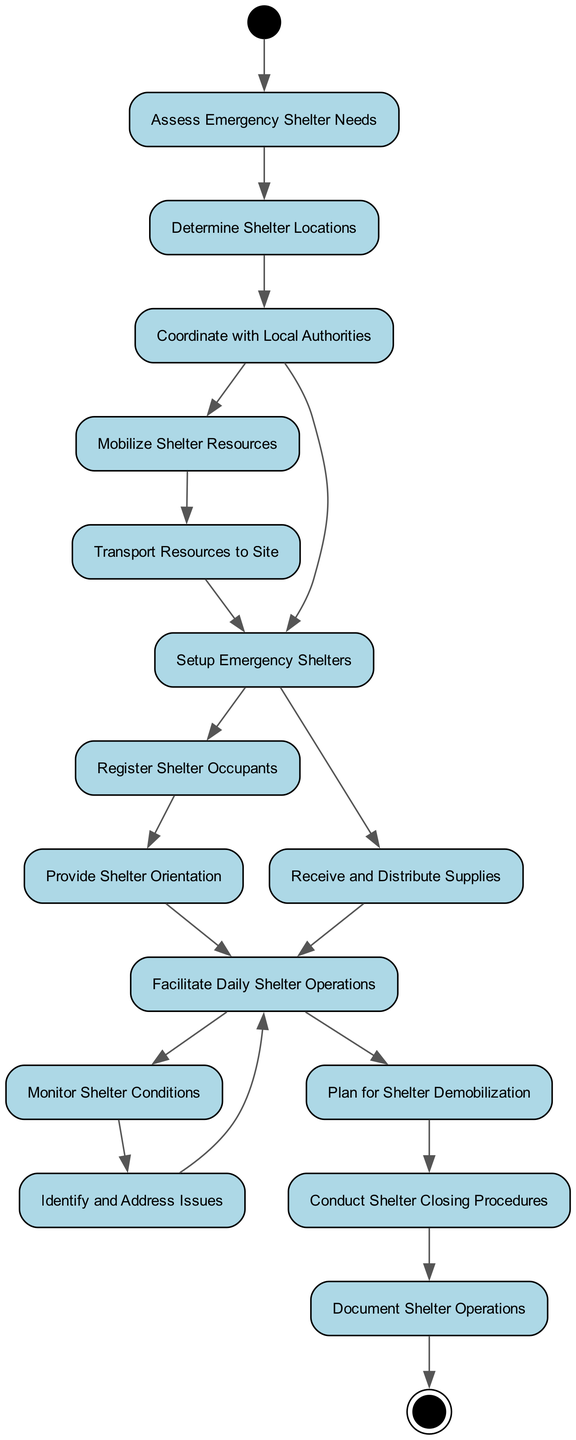What is the first activity in the diagram? The first activity in the diagram is "Assess Emergency Shelter Needs," which is the starting point and has an outgoing edge leading to the next activity.
Answer: Assess Emergency Shelter Needs How many total activities are in the diagram? By counting the individual activities listed in the diagram, there are a total of 15 distinct activities represented as nodes.
Answer: 15 What is the last activity before completing the process? The last activity before reaching the end of the process is "Document Shelter Operations," as it is the final step with no outgoing edges leading to another activity.
Answer: Document Shelter Operations Which activity follows "Provide Shelter Orientation"? The activity that directly follows "Provide Shelter Orientation" is "Facilitate Daily Shelter Operations", according to the transitions shown in the diagram.
Answer: Facilitate Daily Shelter Operations How many transitions are outgoing from "Coordinate with Local Authorities"? There are two outgoing transitions from "Coordinate with Local Authorities," leading to "Mobilize Shelter Resources" and "Setup Emergency Shelters."
Answer: 2 What activity involves the registration of occupants? The activity involving the registration of occupants is "Register Shelter Occupants," which is a key step after setting up emergency shelters.
Answer: Register Shelter Occupants Which activities are directly connected to "Setup Emergency Shelters"? The activities directly connected to "Setup Emergency Shelters" are "Register Shelter Occupants" and "Receive and Distribute Supplies," as both lead from "Setup Emergency Shelters."
Answer: Register Shelter Occupants, Receive and Distribute Supplies What is the activity that comes after "Identify and Address Issues"? The activity that comes after "Identify and Address Issues" is "Facilitate Daily Shelter Operations," indicating a return to regular activities after addressing issues.
Answer: Facilitate Daily Shelter Operations What is the second activity in the sequence? The second activity in the sequence, following "Assess Emergency Shelter Needs," is "Determine Shelter Locations."
Answer: Determine Shelter Locations 